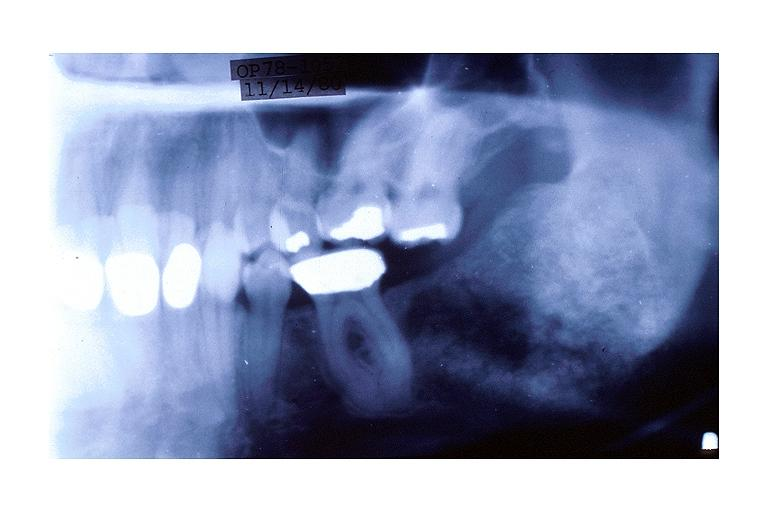what is present?
Answer the question using a single word or phrase. Oral 